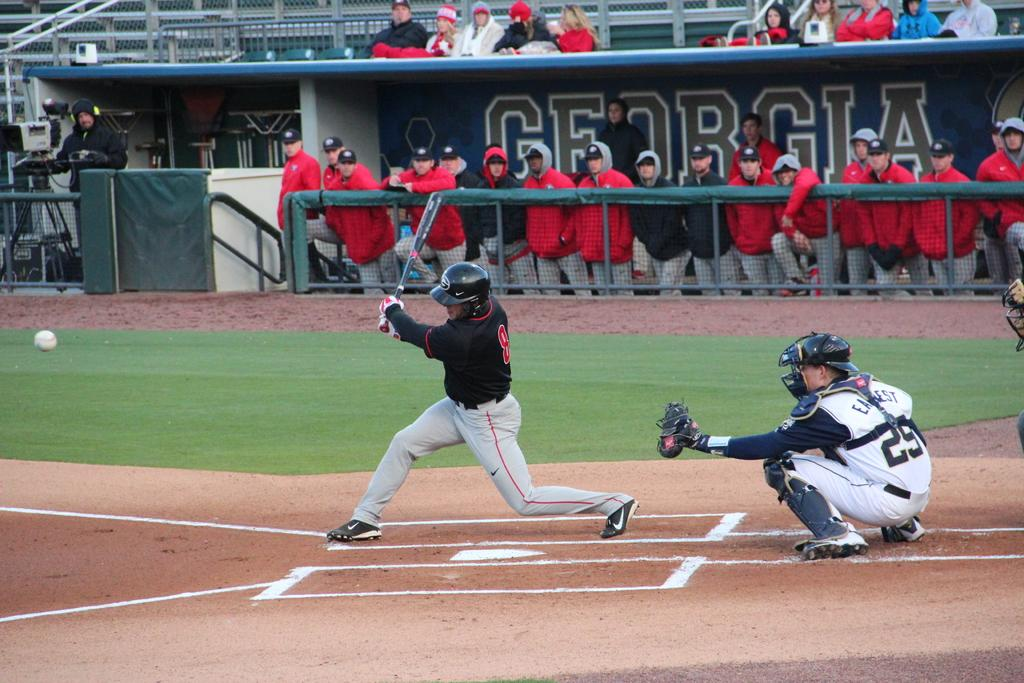<image>
Provide a brief description of the given image. Batter at the plate with Georgia in the background 